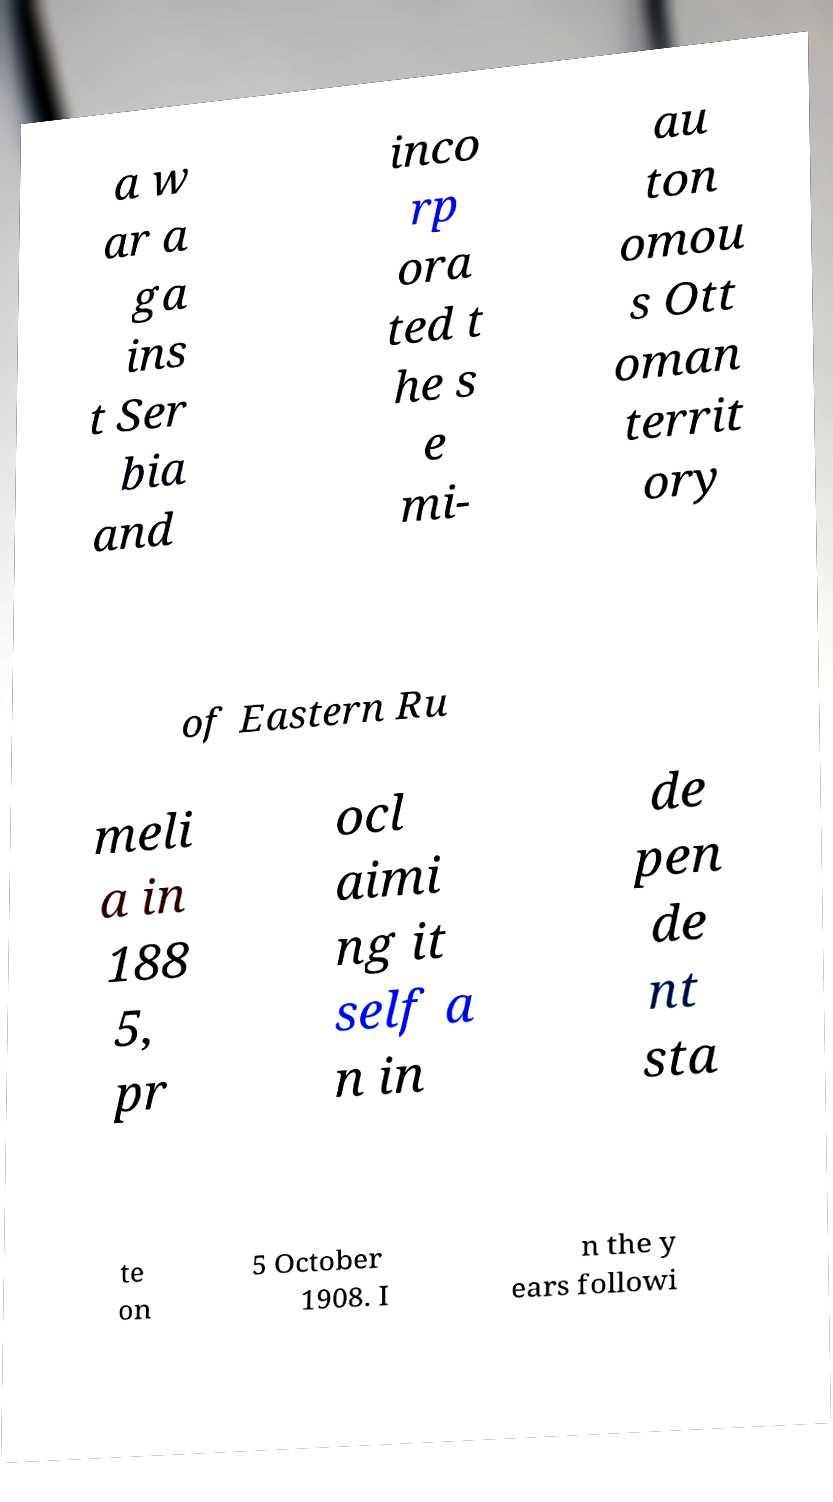What messages or text are displayed in this image? I need them in a readable, typed format. a w ar a ga ins t Ser bia and inco rp ora ted t he s e mi- au ton omou s Ott oman territ ory of Eastern Ru meli a in 188 5, pr ocl aimi ng it self a n in de pen de nt sta te on 5 October 1908. I n the y ears followi 